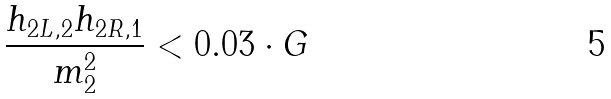Convert formula to latex. <formula><loc_0><loc_0><loc_500><loc_500>\frac { h _ { 2 L , 2 } h _ { 2 R , 1 } } { m _ { 2 } ^ { 2 } } < 0 . 0 3 \cdot G</formula> 